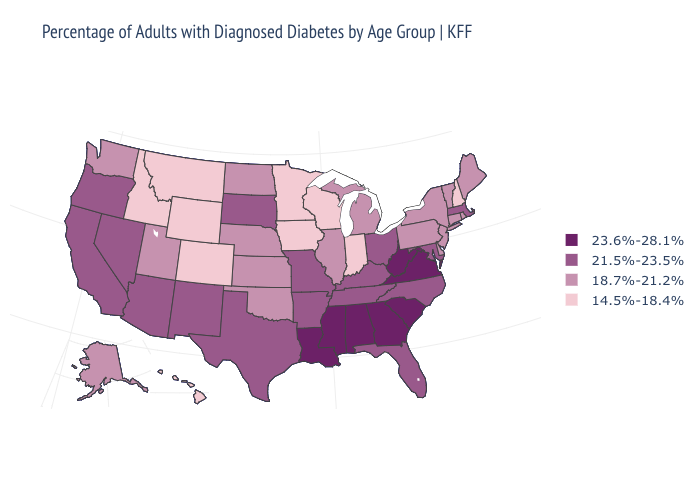Among the states that border North Dakota , which have the highest value?
Give a very brief answer. South Dakota. Is the legend a continuous bar?
Keep it brief. No. Does Virginia have the lowest value in the USA?
Short answer required. No. Does Delaware have the same value as Indiana?
Quick response, please. No. Among the states that border Delaware , does Maryland have the lowest value?
Give a very brief answer. No. What is the value of North Dakota?
Answer briefly. 18.7%-21.2%. What is the value of Massachusetts?
Quick response, please. 21.5%-23.5%. Among the states that border Rhode Island , does Connecticut have the lowest value?
Be succinct. Yes. Does Mississippi have a higher value than California?
Give a very brief answer. Yes. How many symbols are there in the legend?
Give a very brief answer. 4. Does Wyoming have the same value as New Mexico?
Give a very brief answer. No. Which states hav the highest value in the West?
Give a very brief answer. Arizona, California, Nevada, New Mexico, Oregon. Name the states that have a value in the range 18.7%-21.2%?
Give a very brief answer. Alaska, Connecticut, Delaware, Illinois, Kansas, Maine, Michigan, Nebraska, New Jersey, New York, North Dakota, Oklahoma, Pennsylvania, Rhode Island, Utah, Vermont, Washington. Name the states that have a value in the range 21.5%-23.5%?
Concise answer only. Arizona, Arkansas, California, Florida, Kentucky, Maryland, Massachusetts, Missouri, Nevada, New Mexico, North Carolina, Ohio, Oregon, South Dakota, Tennessee, Texas. Name the states that have a value in the range 14.5%-18.4%?
Quick response, please. Colorado, Hawaii, Idaho, Indiana, Iowa, Minnesota, Montana, New Hampshire, Wisconsin, Wyoming. 